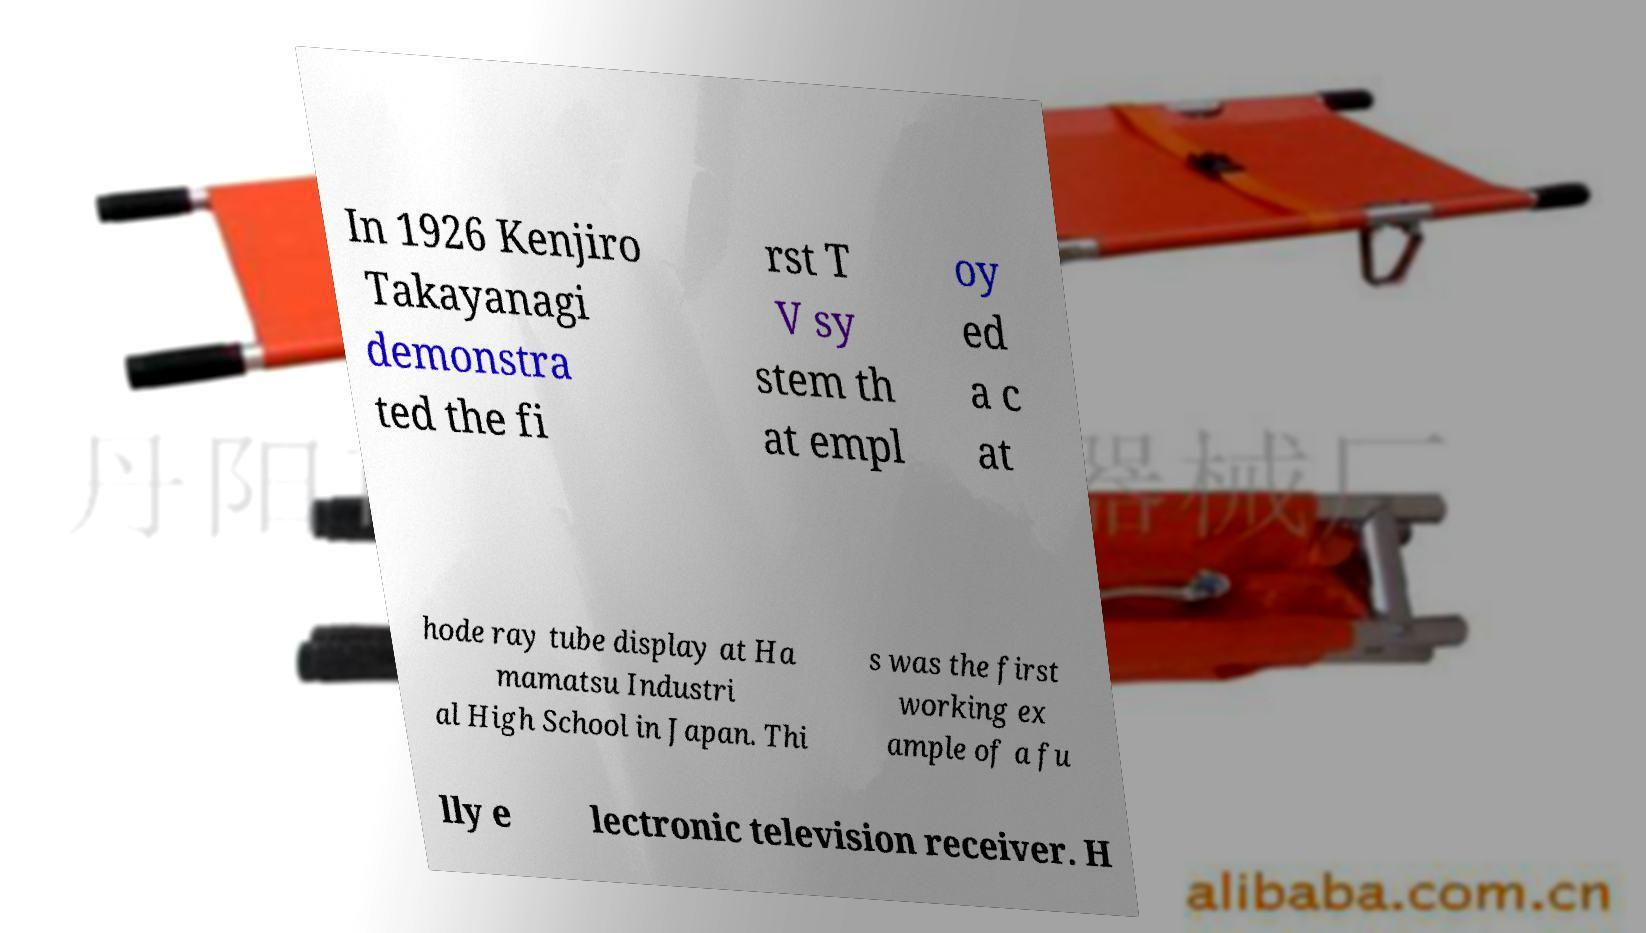There's text embedded in this image that I need extracted. Can you transcribe it verbatim? In 1926 Kenjiro Takayanagi demonstra ted the fi rst T V sy stem th at empl oy ed a c at hode ray tube display at Ha mamatsu Industri al High School in Japan. Thi s was the first working ex ample of a fu lly e lectronic television receiver. H 